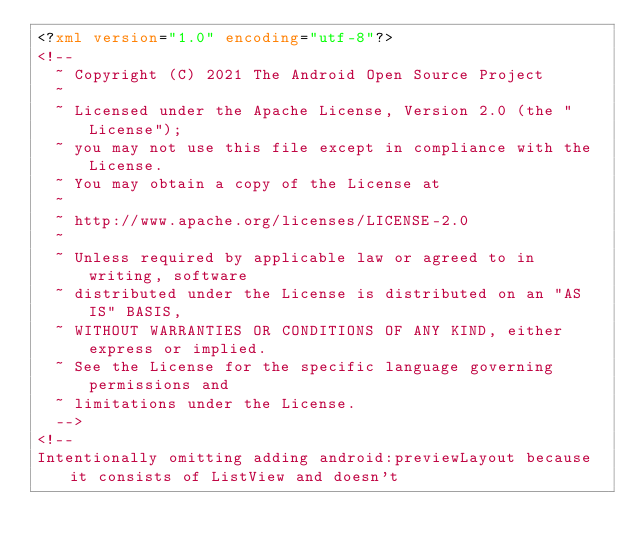<code> <loc_0><loc_0><loc_500><loc_500><_XML_><?xml version="1.0" encoding="utf-8"?>
<!--
  ~ Copyright (C) 2021 The Android Open Source Project
  ~
  ~ Licensed under the Apache License, Version 2.0 (the "License");
  ~ you may not use this file except in compliance with the License.
  ~ You may obtain a copy of the License at
  ~
  ~ http://www.apache.org/licenses/LICENSE-2.0
  ~
  ~ Unless required by applicable law or agreed to in writing, software
  ~ distributed under the License is distributed on an "AS IS" BASIS,
  ~ WITHOUT WARRANTIES OR CONDITIONS OF ANY KIND, either express or implied.
  ~ See the License for the specific language governing permissions and
  ~ limitations under the License.
  -->
<!--
Intentionally omitting adding android:previewLayout because it consists of ListView and doesn't</code> 